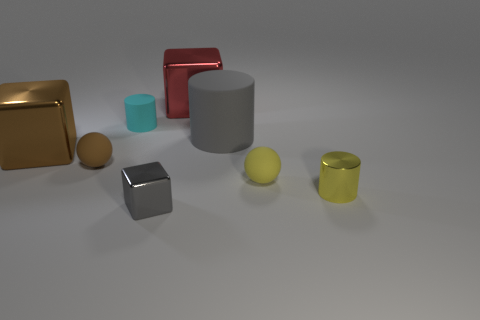Are there any metal blocks that are behind the small ball that is right of the cyan thing? yes 